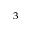Convert formula to latex. <formula><loc_0><loc_0><loc_500><loc_500>_ { 3 }</formula> 